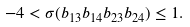<formula> <loc_0><loc_0><loc_500><loc_500>- 4 < \sigma ( b _ { 1 3 } b _ { 1 4 } b _ { 2 3 } b _ { 2 4 } ) \leq 1 .</formula> 